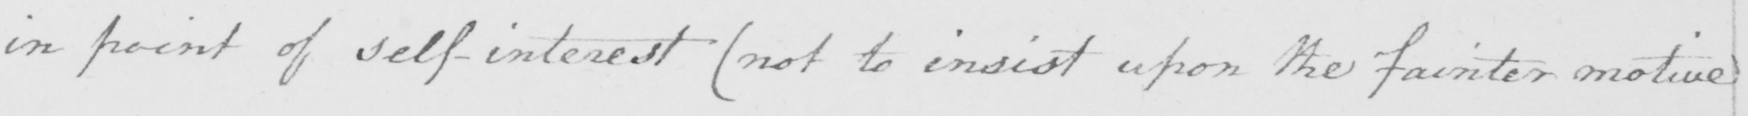What text is written in this handwritten line? in point of self-interest  ( not to insist upon the fainter motive 